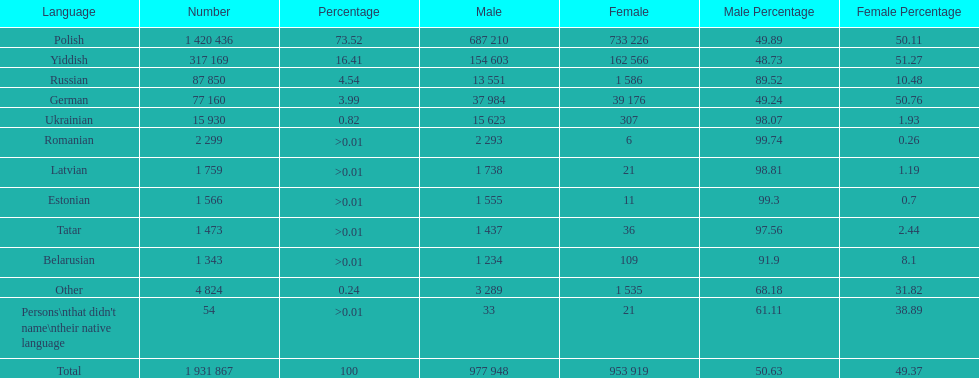The least amount of females Romanian. 